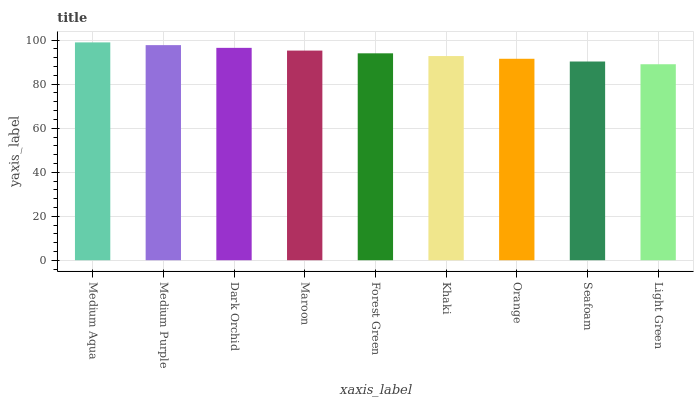Is Light Green the minimum?
Answer yes or no. Yes. Is Medium Aqua the maximum?
Answer yes or no. Yes. Is Medium Purple the minimum?
Answer yes or no. No. Is Medium Purple the maximum?
Answer yes or no. No. Is Medium Aqua greater than Medium Purple?
Answer yes or no. Yes. Is Medium Purple less than Medium Aqua?
Answer yes or no. Yes. Is Medium Purple greater than Medium Aqua?
Answer yes or no. No. Is Medium Aqua less than Medium Purple?
Answer yes or no. No. Is Forest Green the high median?
Answer yes or no. Yes. Is Forest Green the low median?
Answer yes or no. Yes. Is Maroon the high median?
Answer yes or no. No. Is Medium Aqua the low median?
Answer yes or no. No. 